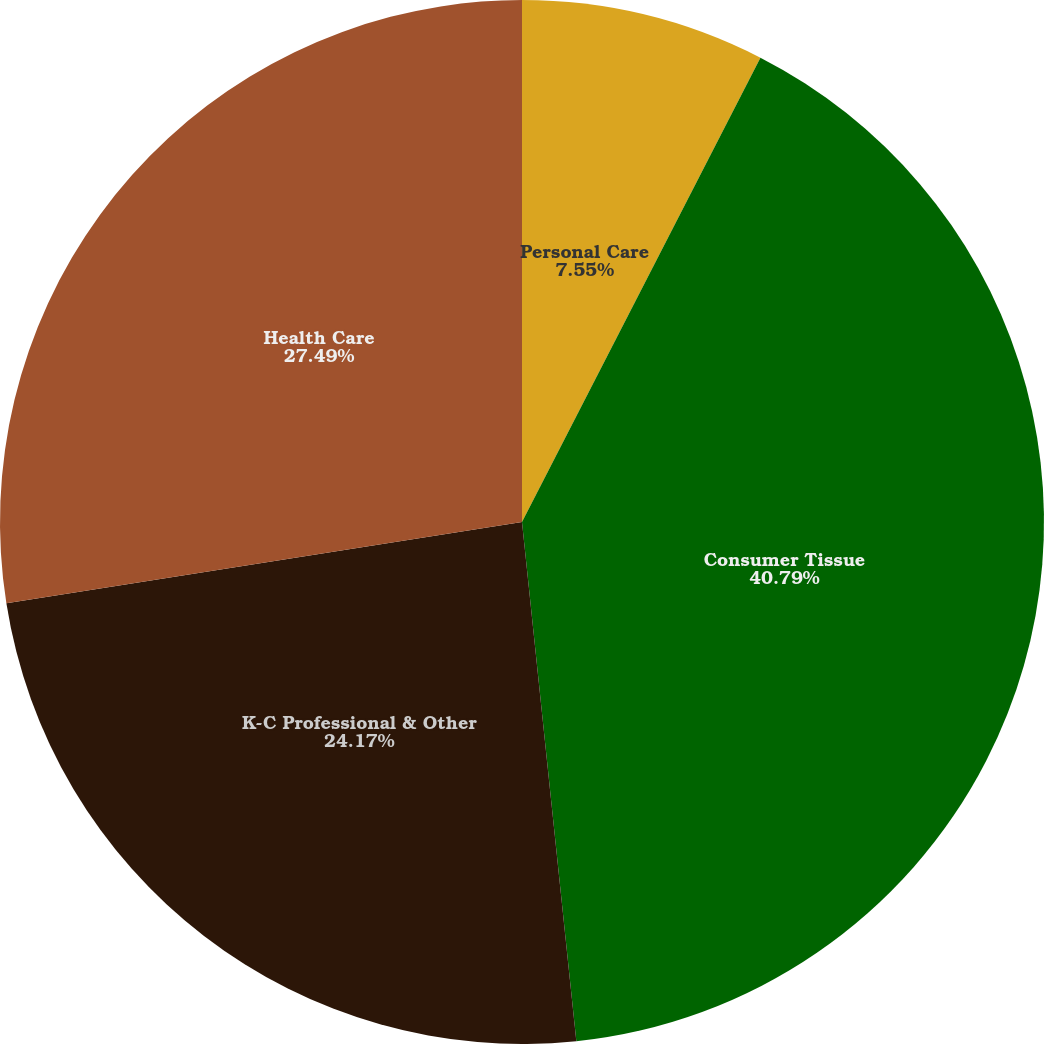Convert chart to OTSL. <chart><loc_0><loc_0><loc_500><loc_500><pie_chart><fcel>Personal Care<fcel>Consumer Tissue<fcel>K-C Professional & Other<fcel>Health Care<nl><fcel>7.55%<fcel>40.79%<fcel>24.17%<fcel>27.49%<nl></chart> 